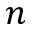Convert formula to latex. <formula><loc_0><loc_0><loc_500><loc_500>n</formula> 